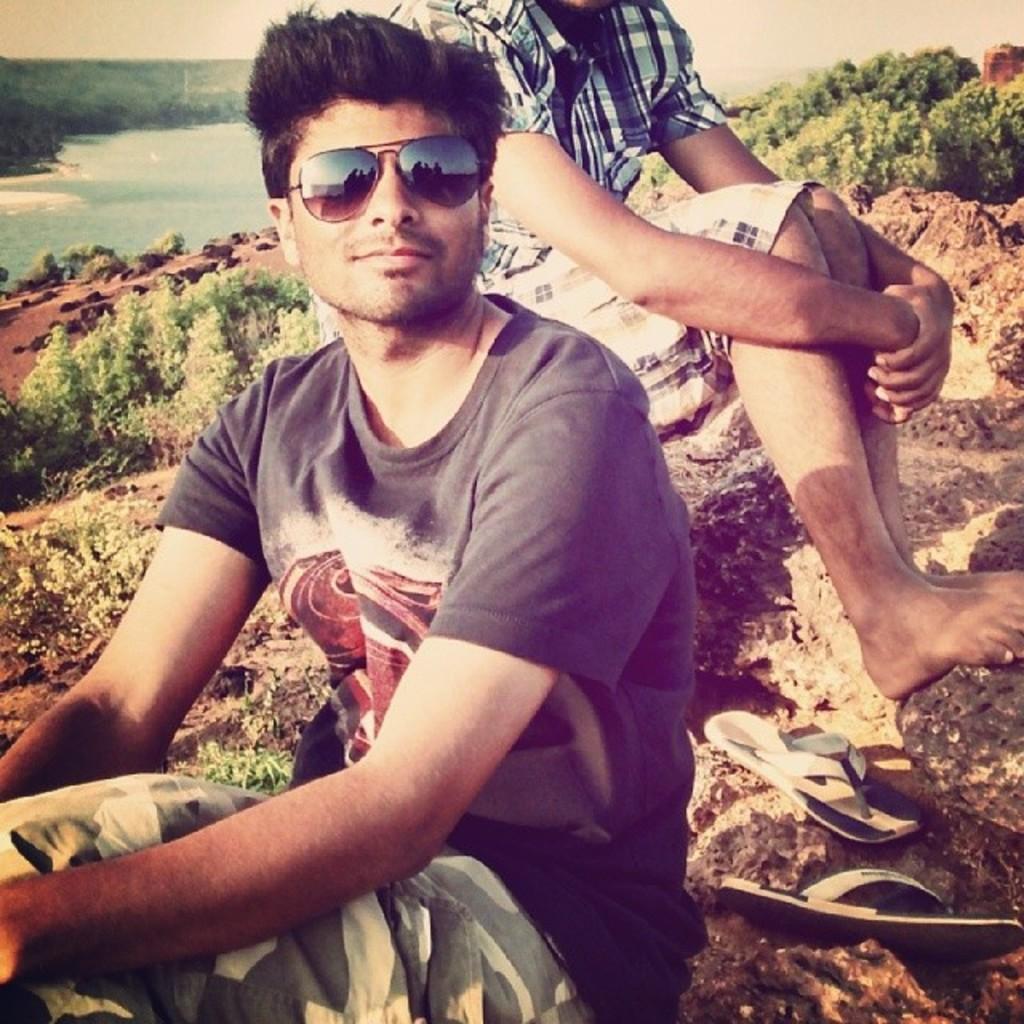Could you give a brief overview of what you see in this image? Here we can see two men sitting on the rock and on the left there is footwear on the rock. In the background we can see plants,stones,water,trees and sky. 